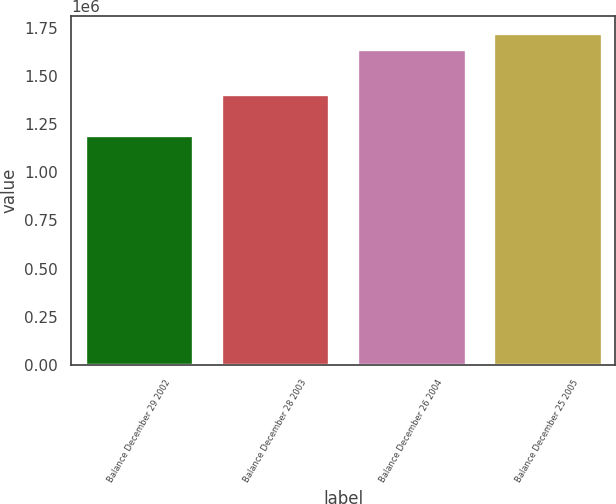Convert chart. <chart><loc_0><loc_0><loc_500><loc_500><bar_chart><fcel>Balance December 29 2002<fcel>Balance December 28 2003<fcel>Balance December 26 2004<fcel>Balance December 25 2005<nl><fcel>1.19137e+06<fcel>1.40524e+06<fcel>1.63972e+06<fcel>1.72348e+06<nl></chart> 